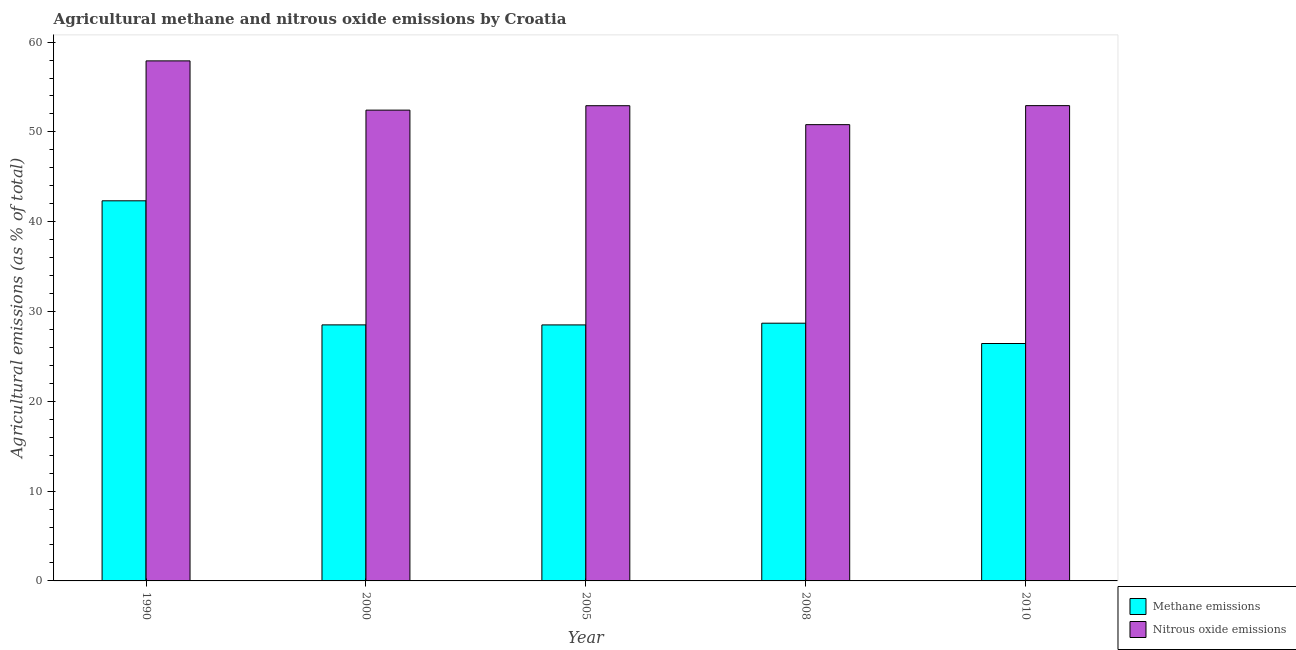How many different coloured bars are there?
Keep it short and to the point. 2. Are the number of bars on each tick of the X-axis equal?
Provide a succinct answer. Yes. How many bars are there on the 3rd tick from the left?
Offer a very short reply. 2. How many bars are there on the 4th tick from the right?
Offer a terse response. 2. What is the label of the 5th group of bars from the left?
Offer a very short reply. 2010. What is the amount of methane emissions in 2000?
Your answer should be compact. 28.51. Across all years, what is the maximum amount of methane emissions?
Give a very brief answer. 42.33. Across all years, what is the minimum amount of methane emissions?
Give a very brief answer. 26.44. In which year was the amount of methane emissions maximum?
Keep it short and to the point. 1990. What is the total amount of methane emissions in the graph?
Your answer should be compact. 154.48. What is the difference between the amount of nitrous oxide emissions in 2008 and that in 2010?
Ensure brevity in your answer.  -2.12. What is the difference between the amount of methane emissions in 1990 and the amount of nitrous oxide emissions in 2008?
Give a very brief answer. 13.63. What is the average amount of nitrous oxide emissions per year?
Your answer should be very brief. 53.39. What is the ratio of the amount of nitrous oxide emissions in 2000 to that in 2010?
Keep it short and to the point. 0.99. What is the difference between the highest and the second highest amount of methane emissions?
Your answer should be very brief. 13.63. What is the difference between the highest and the lowest amount of nitrous oxide emissions?
Offer a terse response. 7.1. What does the 1st bar from the left in 2000 represents?
Ensure brevity in your answer.  Methane emissions. What does the 1st bar from the right in 1990 represents?
Ensure brevity in your answer.  Nitrous oxide emissions. Does the graph contain grids?
Your response must be concise. No. How many legend labels are there?
Make the answer very short. 2. What is the title of the graph?
Ensure brevity in your answer.  Agricultural methane and nitrous oxide emissions by Croatia. Does "Pregnant women" appear as one of the legend labels in the graph?
Your answer should be compact. No. What is the label or title of the Y-axis?
Give a very brief answer. Agricultural emissions (as % of total). What is the Agricultural emissions (as % of total) in Methane emissions in 1990?
Give a very brief answer. 42.33. What is the Agricultural emissions (as % of total) of Nitrous oxide emissions in 1990?
Your response must be concise. 57.91. What is the Agricultural emissions (as % of total) of Methane emissions in 2000?
Offer a terse response. 28.51. What is the Agricultural emissions (as % of total) of Nitrous oxide emissions in 2000?
Give a very brief answer. 52.42. What is the Agricultural emissions (as % of total) of Methane emissions in 2005?
Your answer should be compact. 28.51. What is the Agricultural emissions (as % of total) of Nitrous oxide emissions in 2005?
Make the answer very short. 52.91. What is the Agricultural emissions (as % of total) in Methane emissions in 2008?
Offer a terse response. 28.7. What is the Agricultural emissions (as % of total) in Nitrous oxide emissions in 2008?
Provide a short and direct response. 50.81. What is the Agricultural emissions (as % of total) in Methane emissions in 2010?
Ensure brevity in your answer.  26.44. What is the Agricultural emissions (as % of total) of Nitrous oxide emissions in 2010?
Your response must be concise. 52.92. Across all years, what is the maximum Agricultural emissions (as % of total) in Methane emissions?
Provide a succinct answer. 42.33. Across all years, what is the maximum Agricultural emissions (as % of total) of Nitrous oxide emissions?
Keep it short and to the point. 57.91. Across all years, what is the minimum Agricultural emissions (as % of total) in Methane emissions?
Make the answer very short. 26.44. Across all years, what is the minimum Agricultural emissions (as % of total) in Nitrous oxide emissions?
Provide a short and direct response. 50.81. What is the total Agricultural emissions (as % of total) in Methane emissions in the graph?
Your answer should be very brief. 154.48. What is the total Agricultural emissions (as % of total) of Nitrous oxide emissions in the graph?
Give a very brief answer. 266.97. What is the difference between the Agricultural emissions (as % of total) in Methane emissions in 1990 and that in 2000?
Give a very brief answer. 13.82. What is the difference between the Agricultural emissions (as % of total) of Nitrous oxide emissions in 1990 and that in 2000?
Offer a very short reply. 5.49. What is the difference between the Agricultural emissions (as % of total) of Methane emissions in 1990 and that in 2005?
Your answer should be compact. 13.82. What is the difference between the Agricultural emissions (as % of total) of Nitrous oxide emissions in 1990 and that in 2005?
Your response must be concise. 4.99. What is the difference between the Agricultural emissions (as % of total) of Methane emissions in 1990 and that in 2008?
Make the answer very short. 13.63. What is the difference between the Agricultural emissions (as % of total) of Nitrous oxide emissions in 1990 and that in 2008?
Make the answer very short. 7.1. What is the difference between the Agricultural emissions (as % of total) of Methane emissions in 1990 and that in 2010?
Offer a very short reply. 15.89. What is the difference between the Agricultural emissions (as % of total) of Nitrous oxide emissions in 1990 and that in 2010?
Your response must be concise. 4.98. What is the difference between the Agricultural emissions (as % of total) of Methane emissions in 2000 and that in 2005?
Make the answer very short. 0. What is the difference between the Agricultural emissions (as % of total) in Nitrous oxide emissions in 2000 and that in 2005?
Make the answer very short. -0.49. What is the difference between the Agricultural emissions (as % of total) of Methane emissions in 2000 and that in 2008?
Provide a short and direct response. -0.19. What is the difference between the Agricultural emissions (as % of total) of Nitrous oxide emissions in 2000 and that in 2008?
Offer a very short reply. 1.62. What is the difference between the Agricultural emissions (as % of total) in Methane emissions in 2000 and that in 2010?
Ensure brevity in your answer.  2.08. What is the difference between the Agricultural emissions (as % of total) in Nitrous oxide emissions in 2000 and that in 2010?
Make the answer very short. -0.5. What is the difference between the Agricultural emissions (as % of total) of Methane emissions in 2005 and that in 2008?
Ensure brevity in your answer.  -0.19. What is the difference between the Agricultural emissions (as % of total) of Nitrous oxide emissions in 2005 and that in 2008?
Your answer should be compact. 2.11. What is the difference between the Agricultural emissions (as % of total) in Methane emissions in 2005 and that in 2010?
Provide a succinct answer. 2.07. What is the difference between the Agricultural emissions (as % of total) in Nitrous oxide emissions in 2005 and that in 2010?
Provide a short and direct response. -0.01. What is the difference between the Agricultural emissions (as % of total) in Methane emissions in 2008 and that in 2010?
Offer a very short reply. 2.26. What is the difference between the Agricultural emissions (as % of total) of Nitrous oxide emissions in 2008 and that in 2010?
Ensure brevity in your answer.  -2.12. What is the difference between the Agricultural emissions (as % of total) of Methane emissions in 1990 and the Agricultural emissions (as % of total) of Nitrous oxide emissions in 2000?
Give a very brief answer. -10.1. What is the difference between the Agricultural emissions (as % of total) in Methane emissions in 1990 and the Agricultural emissions (as % of total) in Nitrous oxide emissions in 2005?
Your answer should be compact. -10.59. What is the difference between the Agricultural emissions (as % of total) of Methane emissions in 1990 and the Agricultural emissions (as % of total) of Nitrous oxide emissions in 2008?
Provide a short and direct response. -8.48. What is the difference between the Agricultural emissions (as % of total) in Methane emissions in 1990 and the Agricultural emissions (as % of total) in Nitrous oxide emissions in 2010?
Offer a very short reply. -10.6. What is the difference between the Agricultural emissions (as % of total) in Methane emissions in 2000 and the Agricultural emissions (as % of total) in Nitrous oxide emissions in 2005?
Provide a succinct answer. -24.4. What is the difference between the Agricultural emissions (as % of total) in Methane emissions in 2000 and the Agricultural emissions (as % of total) in Nitrous oxide emissions in 2008?
Keep it short and to the point. -22.3. What is the difference between the Agricultural emissions (as % of total) of Methane emissions in 2000 and the Agricultural emissions (as % of total) of Nitrous oxide emissions in 2010?
Keep it short and to the point. -24.41. What is the difference between the Agricultural emissions (as % of total) of Methane emissions in 2005 and the Agricultural emissions (as % of total) of Nitrous oxide emissions in 2008?
Offer a very short reply. -22.3. What is the difference between the Agricultural emissions (as % of total) in Methane emissions in 2005 and the Agricultural emissions (as % of total) in Nitrous oxide emissions in 2010?
Ensure brevity in your answer.  -24.42. What is the difference between the Agricultural emissions (as % of total) in Methane emissions in 2008 and the Agricultural emissions (as % of total) in Nitrous oxide emissions in 2010?
Your answer should be compact. -24.23. What is the average Agricultural emissions (as % of total) in Methane emissions per year?
Ensure brevity in your answer.  30.9. What is the average Agricultural emissions (as % of total) of Nitrous oxide emissions per year?
Provide a succinct answer. 53.39. In the year 1990, what is the difference between the Agricultural emissions (as % of total) of Methane emissions and Agricultural emissions (as % of total) of Nitrous oxide emissions?
Keep it short and to the point. -15.58. In the year 2000, what is the difference between the Agricultural emissions (as % of total) of Methane emissions and Agricultural emissions (as % of total) of Nitrous oxide emissions?
Give a very brief answer. -23.91. In the year 2005, what is the difference between the Agricultural emissions (as % of total) in Methane emissions and Agricultural emissions (as % of total) in Nitrous oxide emissions?
Provide a succinct answer. -24.41. In the year 2008, what is the difference between the Agricultural emissions (as % of total) in Methane emissions and Agricultural emissions (as % of total) in Nitrous oxide emissions?
Keep it short and to the point. -22.11. In the year 2010, what is the difference between the Agricultural emissions (as % of total) of Methane emissions and Agricultural emissions (as % of total) of Nitrous oxide emissions?
Ensure brevity in your answer.  -26.49. What is the ratio of the Agricultural emissions (as % of total) of Methane emissions in 1990 to that in 2000?
Make the answer very short. 1.48. What is the ratio of the Agricultural emissions (as % of total) of Nitrous oxide emissions in 1990 to that in 2000?
Ensure brevity in your answer.  1.1. What is the ratio of the Agricultural emissions (as % of total) in Methane emissions in 1990 to that in 2005?
Your response must be concise. 1.48. What is the ratio of the Agricultural emissions (as % of total) of Nitrous oxide emissions in 1990 to that in 2005?
Your answer should be compact. 1.09. What is the ratio of the Agricultural emissions (as % of total) of Methane emissions in 1990 to that in 2008?
Offer a terse response. 1.47. What is the ratio of the Agricultural emissions (as % of total) in Nitrous oxide emissions in 1990 to that in 2008?
Offer a terse response. 1.14. What is the ratio of the Agricultural emissions (as % of total) in Methane emissions in 1990 to that in 2010?
Your answer should be very brief. 1.6. What is the ratio of the Agricultural emissions (as % of total) of Nitrous oxide emissions in 1990 to that in 2010?
Your answer should be compact. 1.09. What is the ratio of the Agricultural emissions (as % of total) of Nitrous oxide emissions in 2000 to that in 2008?
Your answer should be compact. 1.03. What is the ratio of the Agricultural emissions (as % of total) of Methane emissions in 2000 to that in 2010?
Offer a terse response. 1.08. What is the ratio of the Agricultural emissions (as % of total) of Nitrous oxide emissions in 2005 to that in 2008?
Your answer should be compact. 1.04. What is the ratio of the Agricultural emissions (as % of total) of Methane emissions in 2005 to that in 2010?
Your response must be concise. 1.08. What is the ratio of the Agricultural emissions (as % of total) of Methane emissions in 2008 to that in 2010?
Ensure brevity in your answer.  1.09. What is the ratio of the Agricultural emissions (as % of total) of Nitrous oxide emissions in 2008 to that in 2010?
Provide a short and direct response. 0.96. What is the difference between the highest and the second highest Agricultural emissions (as % of total) in Methane emissions?
Offer a terse response. 13.63. What is the difference between the highest and the second highest Agricultural emissions (as % of total) of Nitrous oxide emissions?
Give a very brief answer. 4.98. What is the difference between the highest and the lowest Agricultural emissions (as % of total) of Methane emissions?
Ensure brevity in your answer.  15.89. What is the difference between the highest and the lowest Agricultural emissions (as % of total) of Nitrous oxide emissions?
Give a very brief answer. 7.1. 